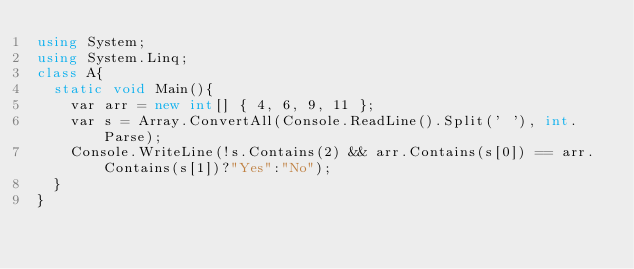Convert code to text. <code><loc_0><loc_0><loc_500><loc_500><_C#_>using System;
using System.Linq;
class A{
  static void Main(){
    var arr = new int[] { 4, 6, 9, 11 };
    var s = Array.ConvertAll(Console.ReadLine().Split(' '), int.Parse);
    Console.WriteLine(!s.Contains(2) && arr.Contains(s[0]) == arr.Contains(s[1])?"Yes":"No");
  }
}</code> 